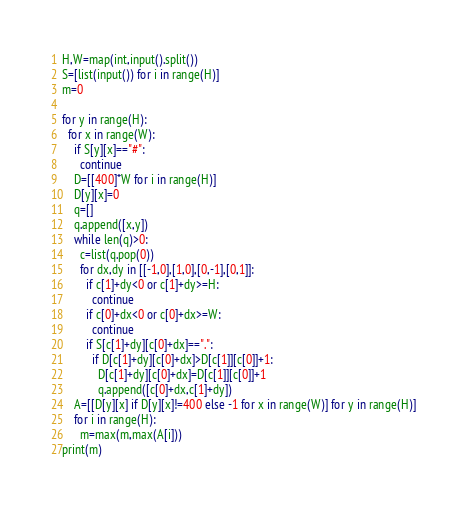Convert code to text. <code><loc_0><loc_0><loc_500><loc_500><_Python_>H,W=map(int,input().split())
S=[list(input()) for i in range(H)]
m=0

for y in range(H):
  for x in range(W):
    if S[y][x]=="#":
      continue
    D=[[400]*W for i in range(H)]
    D[y][x]=0
    q=[]
    q.append([x,y])
    while len(q)>0:
      c=list(q.pop(0))
      for dx,dy in [[-1,0],[1,0],[0,-1],[0,1]]:
        if c[1]+dy<0 or c[1]+dy>=H:
          continue
        if c[0]+dx<0 or c[0]+dx>=W:
          continue
        if S[c[1]+dy][c[0]+dx]==".":
          if D[c[1]+dy][c[0]+dx]>D[c[1]][c[0]]+1:
            D[c[1]+dy][c[0]+dx]=D[c[1]][c[0]]+1
            q.append([c[0]+dx,c[1]+dy])
    A=[[D[y][x] if D[y][x]!=400 else -1 for x in range(W)] for y in range(H)]
    for i in range(H):
      m=max(m,max(A[i]))
print(m)</code> 